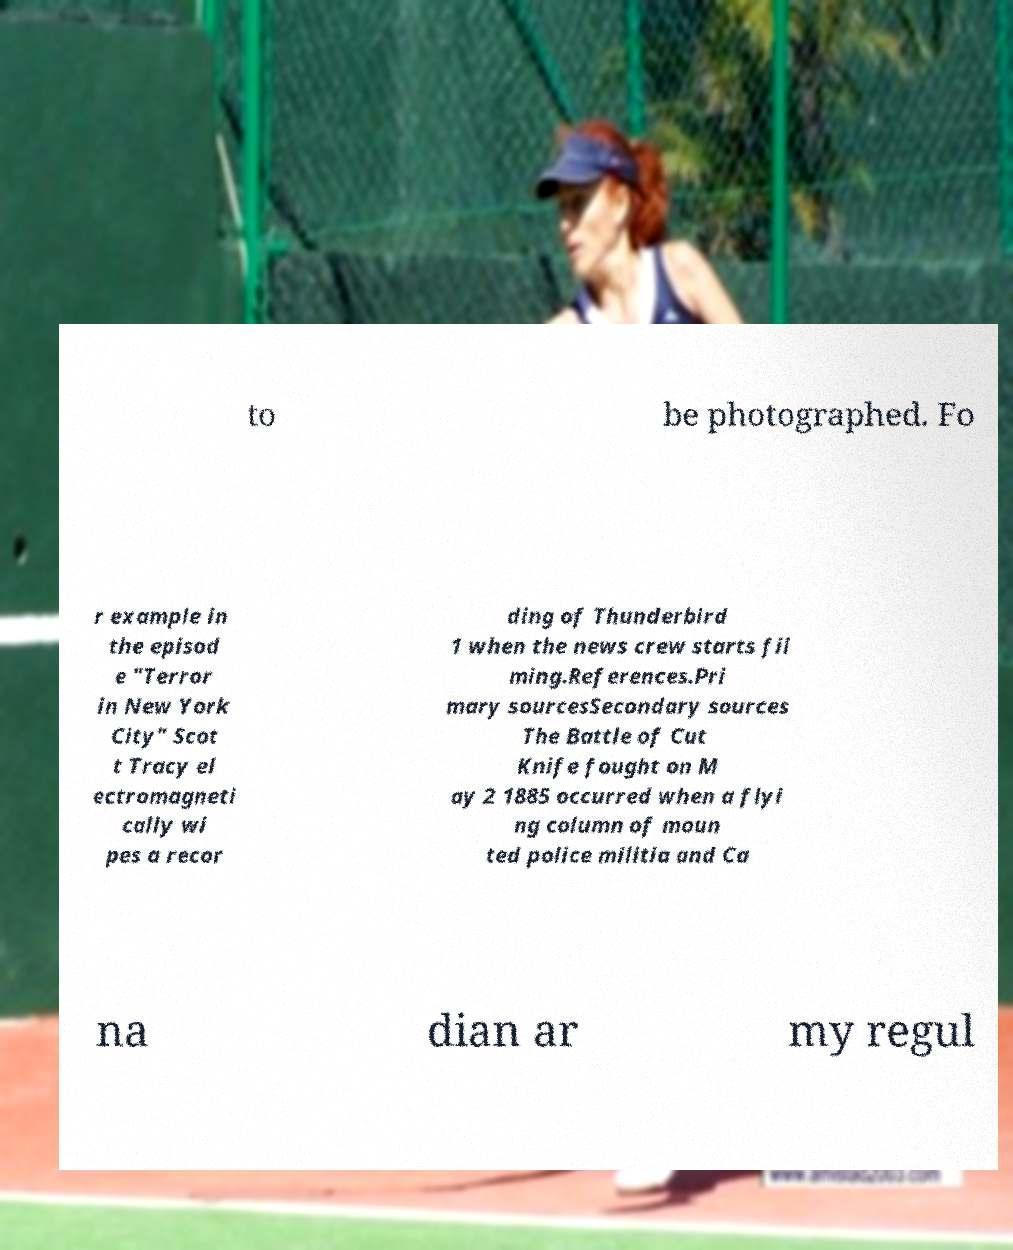Please read and relay the text visible in this image. What does it say? to be photographed. Fo r example in the episod e "Terror in New York City" Scot t Tracy el ectromagneti cally wi pes a recor ding of Thunderbird 1 when the news crew starts fil ming.References.Pri mary sourcesSecondary sources The Battle of Cut Knife fought on M ay 2 1885 occurred when a flyi ng column of moun ted police militia and Ca na dian ar my regul 